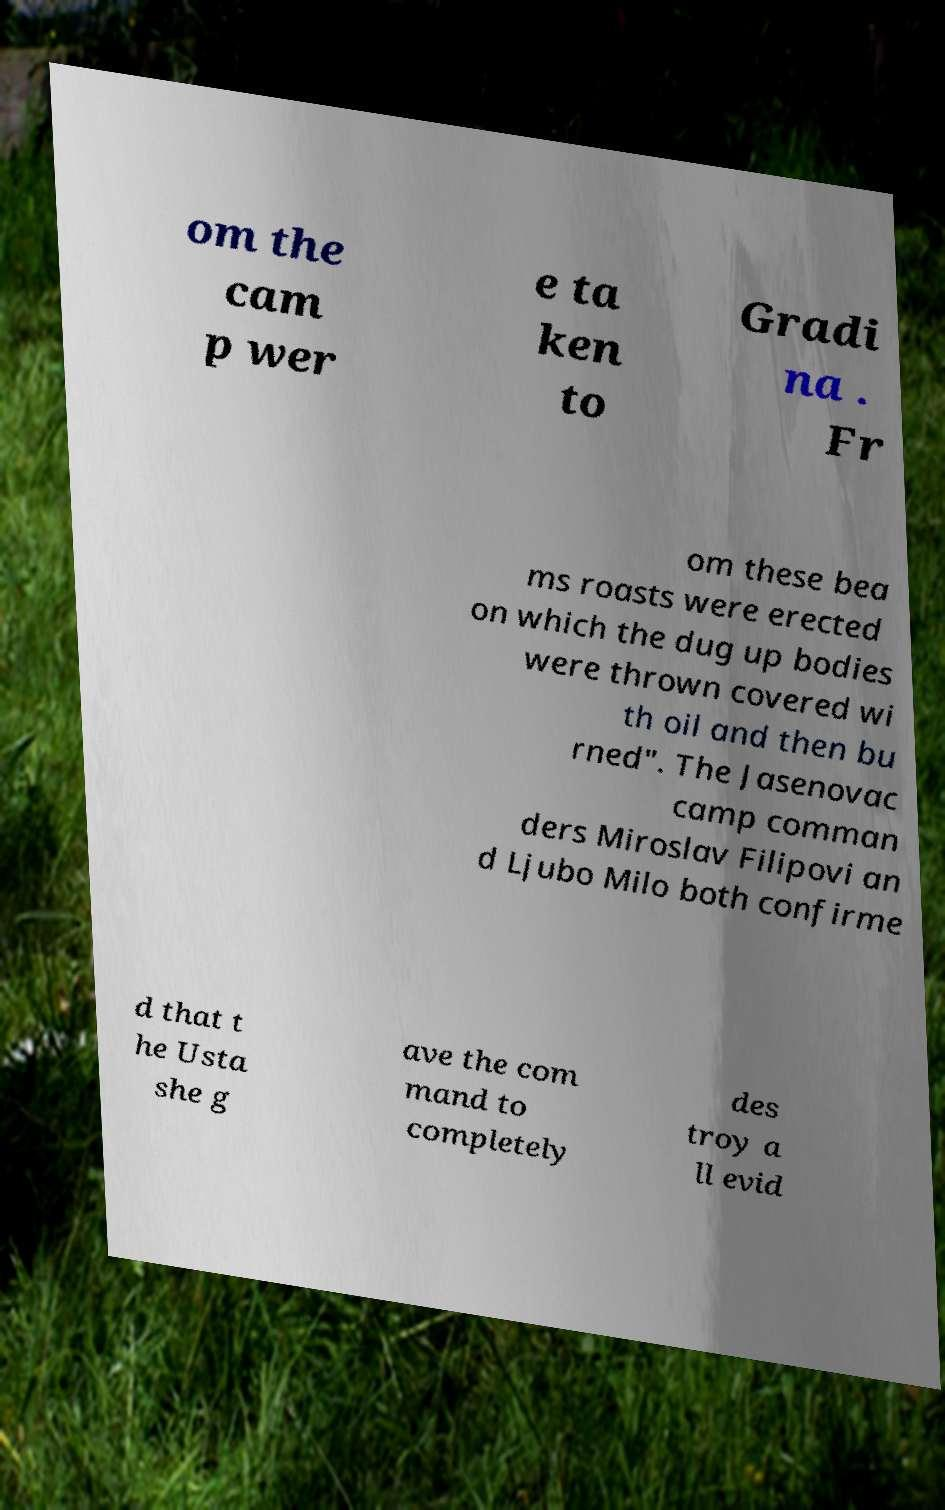I need the written content from this picture converted into text. Can you do that? om the cam p wer e ta ken to Gradi na . Fr om these bea ms roasts were erected on which the dug up bodies were thrown covered wi th oil and then bu rned". The Jasenovac camp comman ders Miroslav Filipovi an d Ljubo Milo both confirme d that t he Usta she g ave the com mand to completely des troy a ll evid 